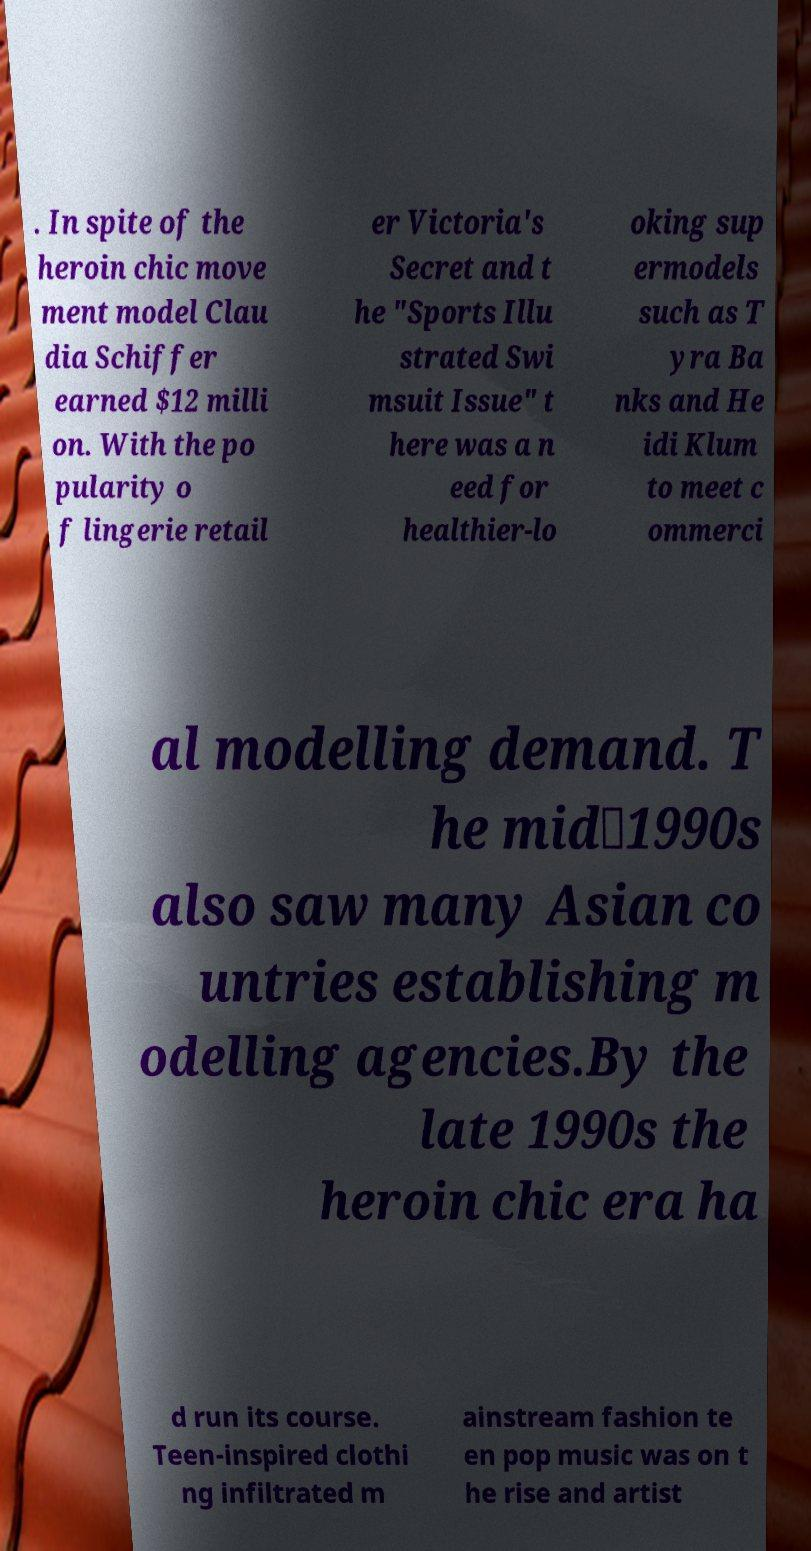What messages or text are displayed in this image? I need them in a readable, typed format. . In spite of the heroin chic move ment model Clau dia Schiffer earned $12 milli on. With the po pularity o f lingerie retail er Victoria's Secret and t he "Sports Illu strated Swi msuit Issue" t here was a n eed for healthier-lo oking sup ermodels such as T yra Ba nks and He idi Klum to meet c ommerci al modelling demand. T he mid‑1990s also saw many Asian co untries establishing m odelling agencies.By the late 1990s the heroin chic era ha d run its course. Teen-inspired clothi ng infiltrated m ainstream fashion te en pop music was on t he rise and artist 